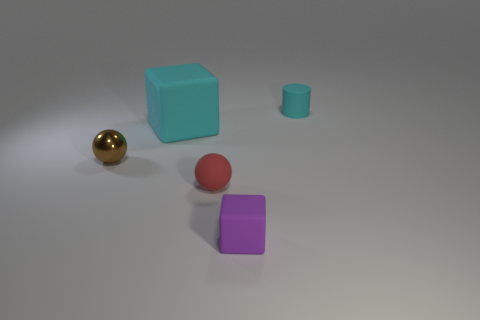Is there another ball of the same color as the small matte ball?
Provide a succinct answer. No. There is a cyan thing that is the same size as the red rubber ball; what is its shape?
Give a very brief answer. Cylinder. What number of small purple matte objects are to the right of the matte block that is on the right side of the cyan block?
Keep it short and to the point. 0. Do the small metallic sphere and the tiny matte cylinder have the same color?
Your answer should be compact. No. How many other objects are the same material as the brown thing?
Make the answer very short. 0. There is a cyan object to the left of the cyan matte thing to the right of the tiny red matte sphere; what is its shape?
Your response must be concise. Cube. There is a cube to the right of the large cyan thing; what is its size?
Provide a succinct answer. Small. Is the small purple object made of the same material as the brown ball?
Provide a short and direct response. No. What shape is the purple thing that is the same material as the small red ball?
Offer a very short reply. Cube. Is there anything else that has the same color as the big block?
Provide a succinct answer. Yes. 